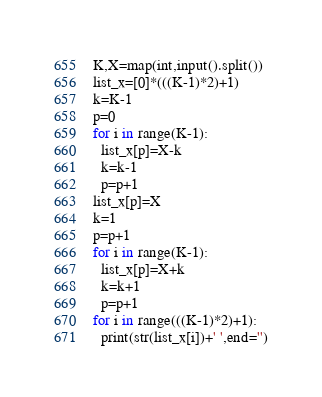<code> <loc_0><loc_0><loc_500><loc_500><_Python_>K,X=map(int,input().split())
list_x=[0]*(((K-1)*2)+1)
k=K-1
p=0
for i in range(K-1):
  list_x[p]=X-k
  k=k-1
  p=p+1
list_x[p]=X
k=1
p=p+1
for i in range(K-1):
  list_x[p]=X+k
  k=k+1
  p=p+1
for i in range(((K-1)*2)+1):
  print(str(list_x[i])+' ',end='')
</code> 